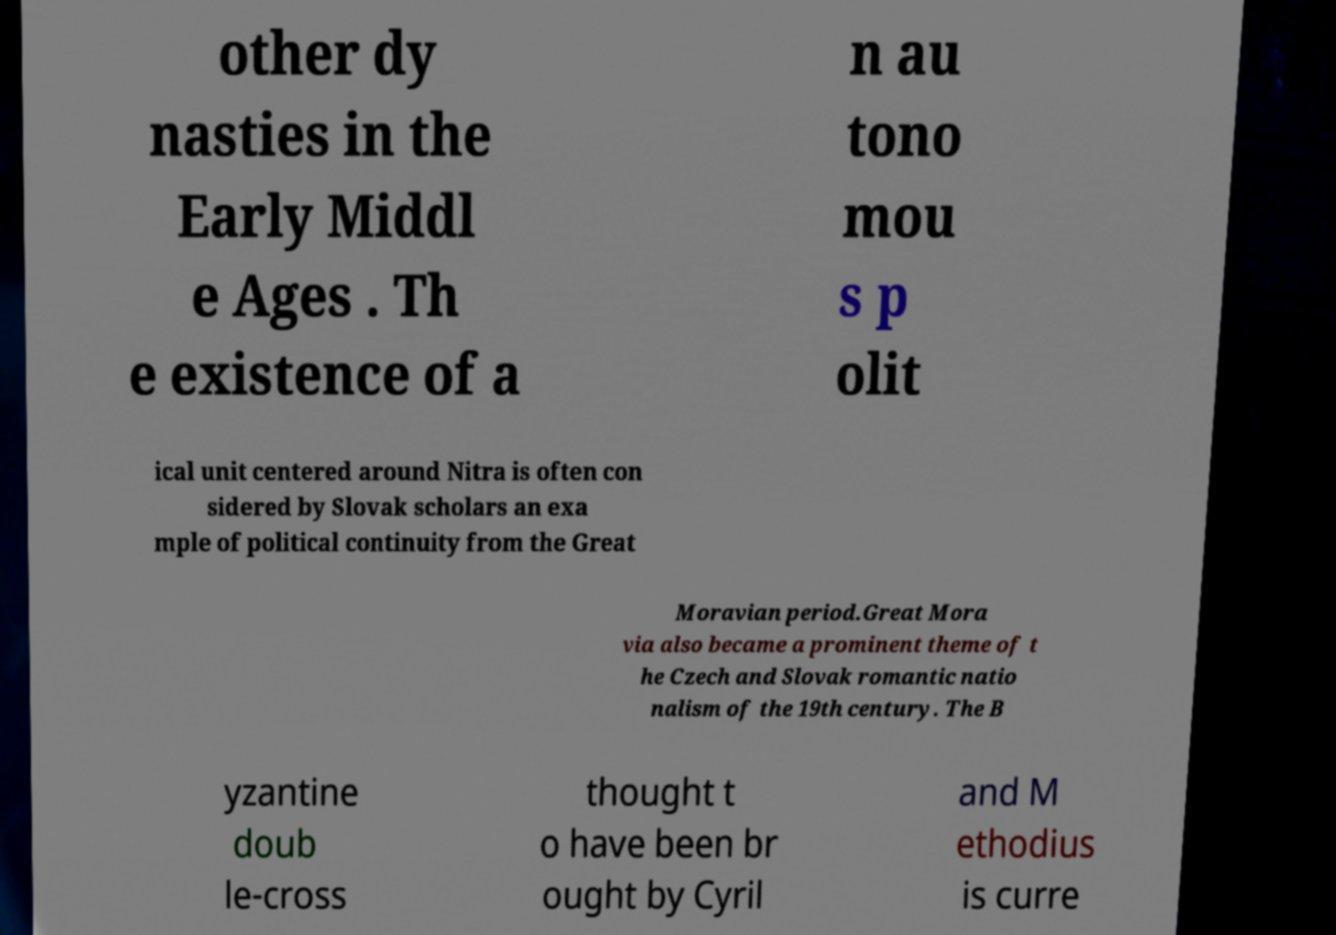Could you assist in decoding the text presented in this image and type it out clearly? other dy nasties in the Early Middl e Ages . Th e existence of a n au tono mou s p olit ical unit centered around Nitra is often con sidered by Slovak scholars an exa mple of political continuity from the Great Moravian period.Great Mora via also became a prominent theme of t he Czech and Slovak romantic natio nalism of the 19th century. The B yzantine doub le-cross thought t o have been br ought by Cyril and M ethodius is curre 